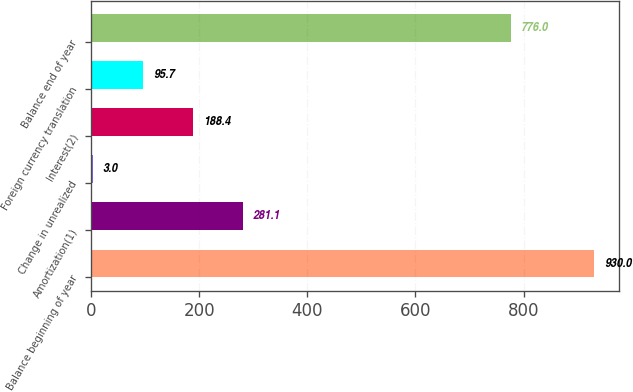Convert chart. <chart><loc_0><loc_0><loc_500><loc_500><bar_chart><fcel>Balance beginning of year<fcel>Amortization(1)<fcel>Change in unrealized<fcel>Interest(2)<fcel>Foreign currency translation<fcel>Balance end of year<nl><fcel>930<fcel>281.1<fcel>3<fcel>188.4<fcel>95.7<fcel>776<nl></chart> 